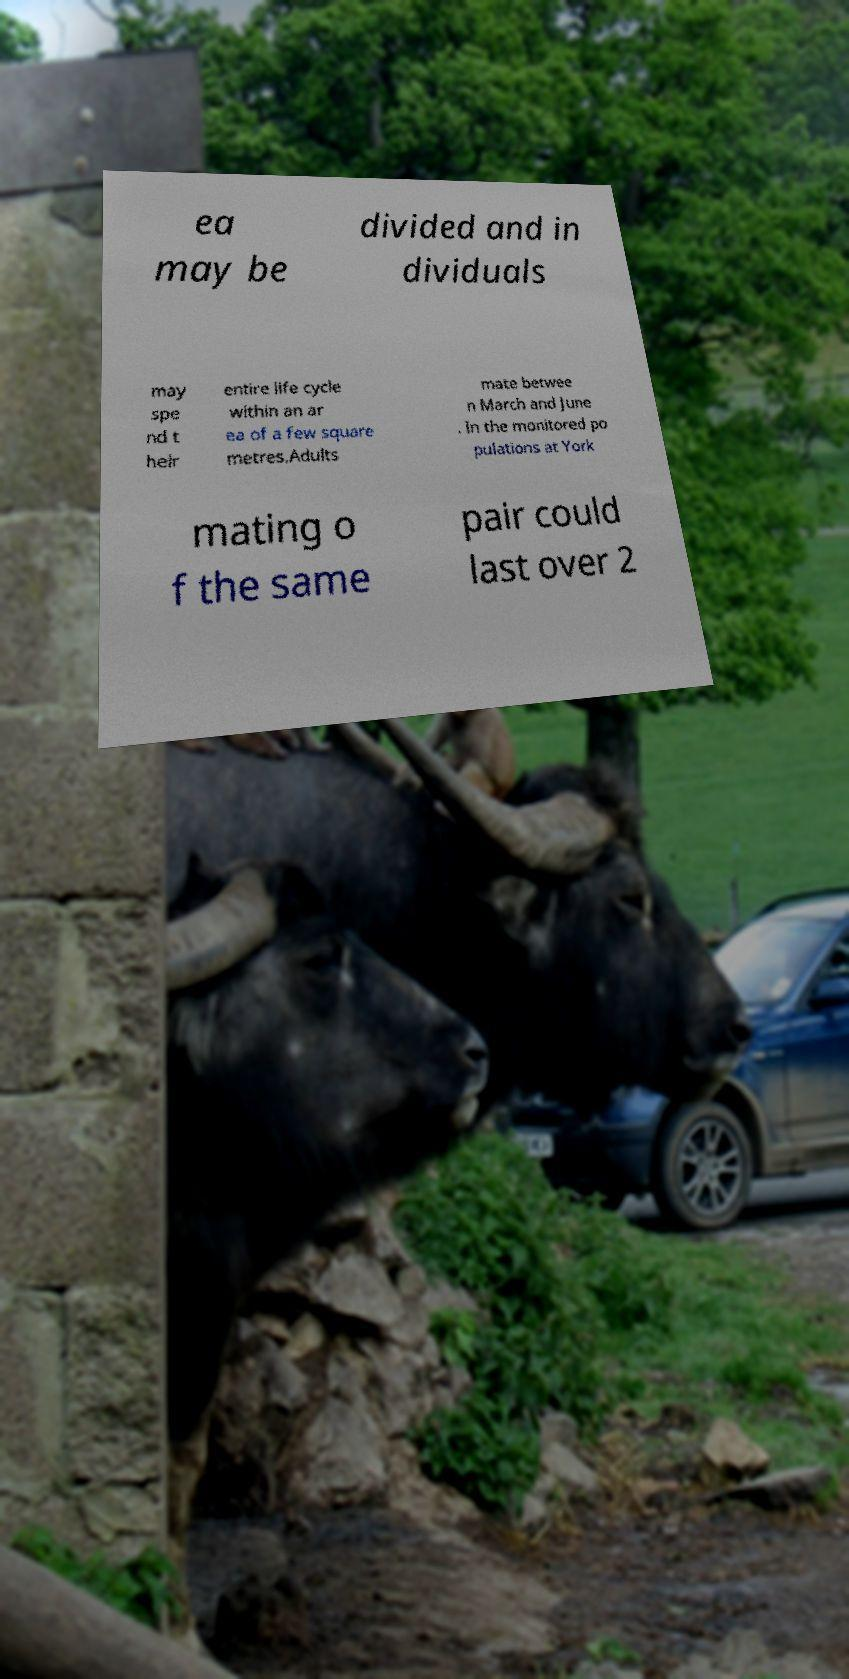Please read and relay the text visible in this image. What does it say? ea may be divided and in dividuals may spe nd t heir entire life cycle within an ar ea of a few square metres.Adults mate betwee n March and June . In the monitored po pulations at York mating o f the same pair could last over 2 